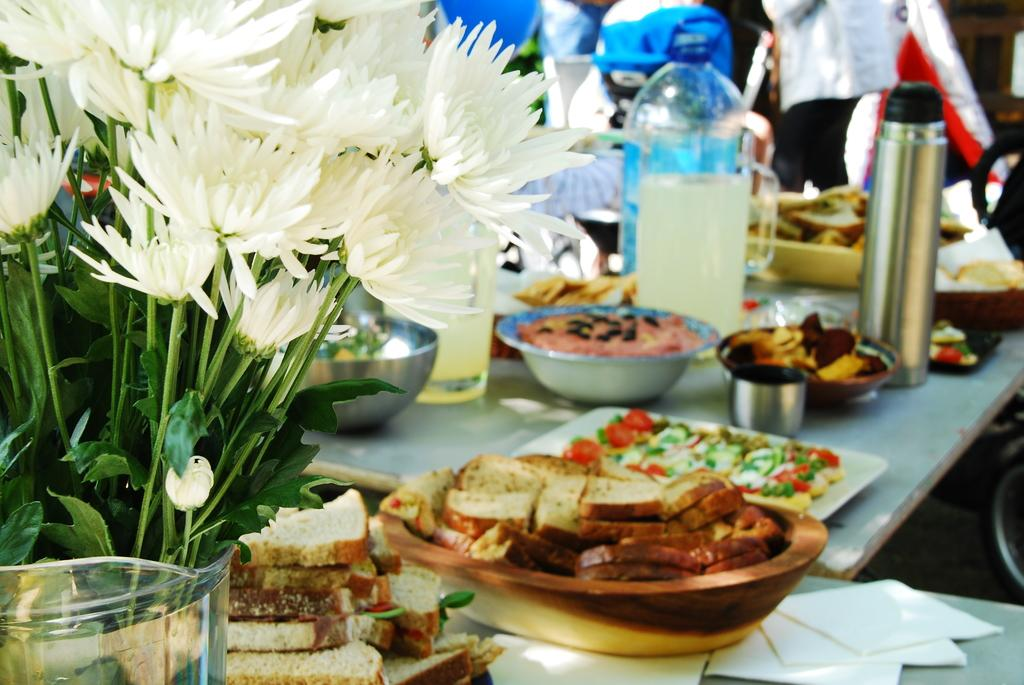What type of furniture is present in the image? There is a table in the image. What is placed on the table? Food items are placed on the table. What type of container is visible in the image? There is a glass jar and a bottle in the image. What type of decoration is present on the table? There are flowers in a flower vase on the table. What is the purpose of the lamp in the image? There is no lamp present in the image. 